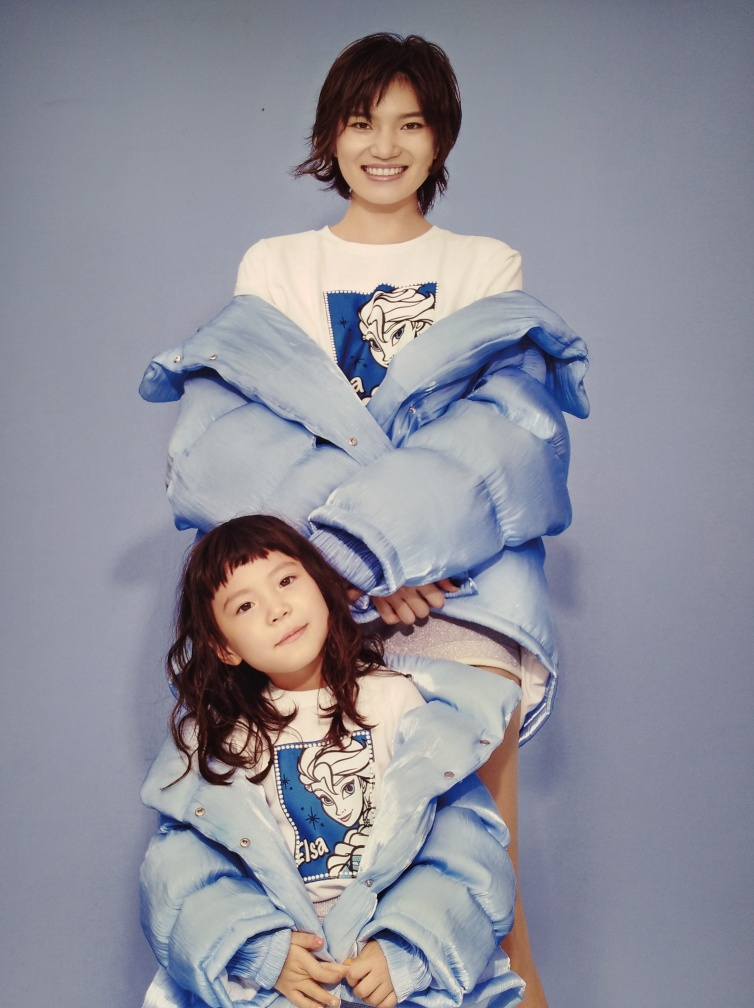How does the attire of the subjects contribute to the overall composition of this image? The attire of the individuals, notably the matching oversized blue denim jackets, creates a vibrant and playful atmosphere that draws the eye. The element of shared style fosters a sense of connection between the two, while also adding a pop of color against the neutral background, contributing to a cohesive and engaging aesthetic. Do the expressions of the individuals tell us anything about their possible relationship? Their expressions exude warmth and happiness, suggesting a close and affectionate relationship. The mirroring of their genuine smiles and relaxed postures implies a comfortable, joyful bond, which could indicate they are family members or share a bond akin to that of siblings or close friends. 